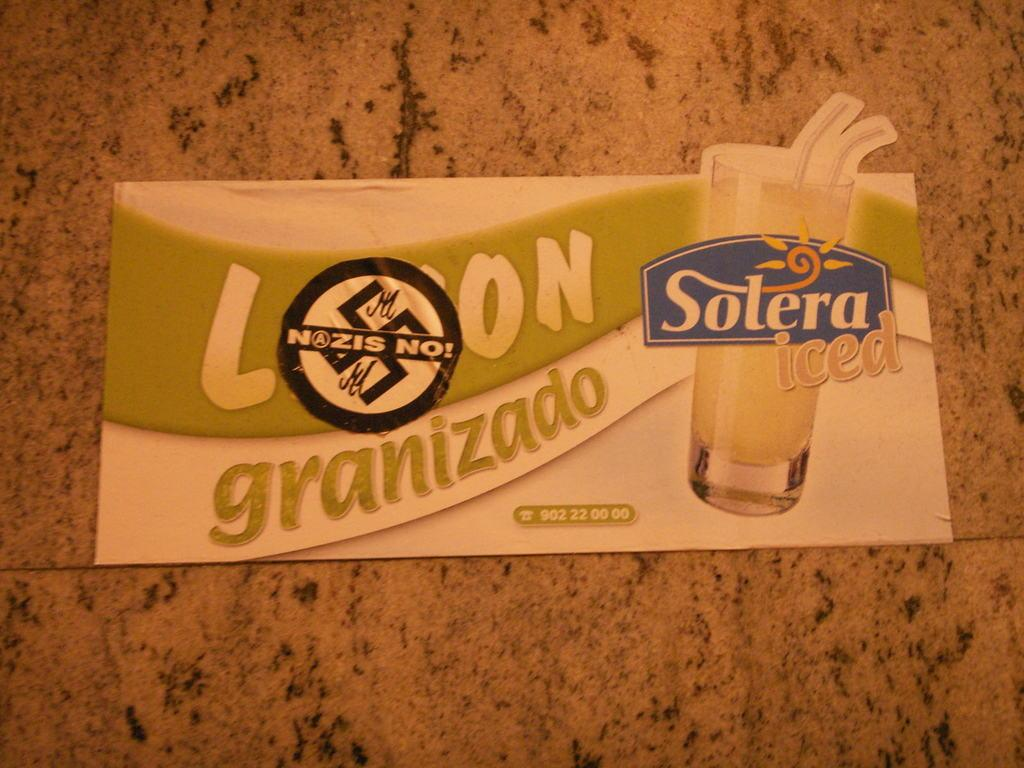What is the main object in the center of the image? There is a pamphlet in the center of the image. What type of surface is the pamphlet resting on? The pamphlet is on a tile. What type of arch can be seen in the image? There is no arch present in the image; it only features a pamphlet on a tile. 